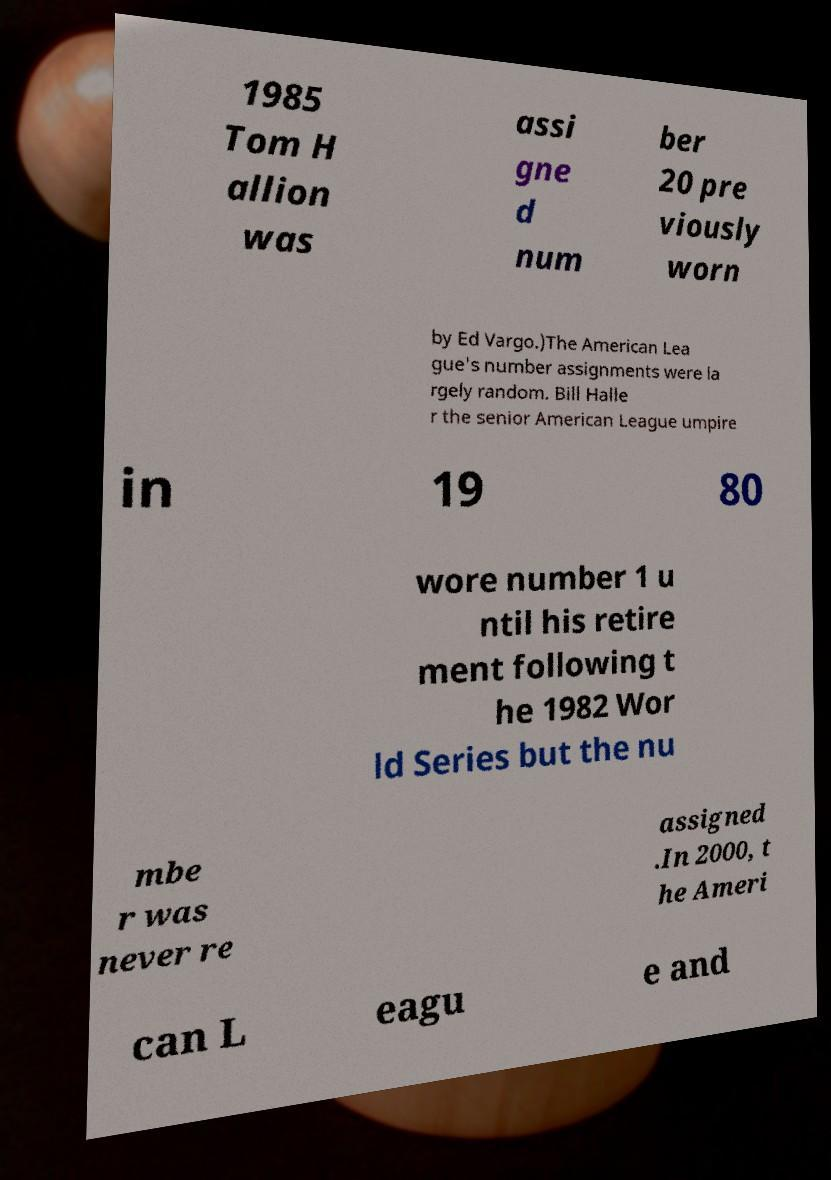Could you extract and type out the text from this image? 1985 Tom H allion was assi gne d num ber 20 pre viously worn by Ed Vargo.)The American Lea gue's number assignments were la rgely random. Bill Halle r the senior American League umpire in 19 80 wore number 1 u ntil his retire ment following t he 1982 Wor ld Series but the nu mbe r was never re assigned .In 2000, t he Ameri can L eagu e and 